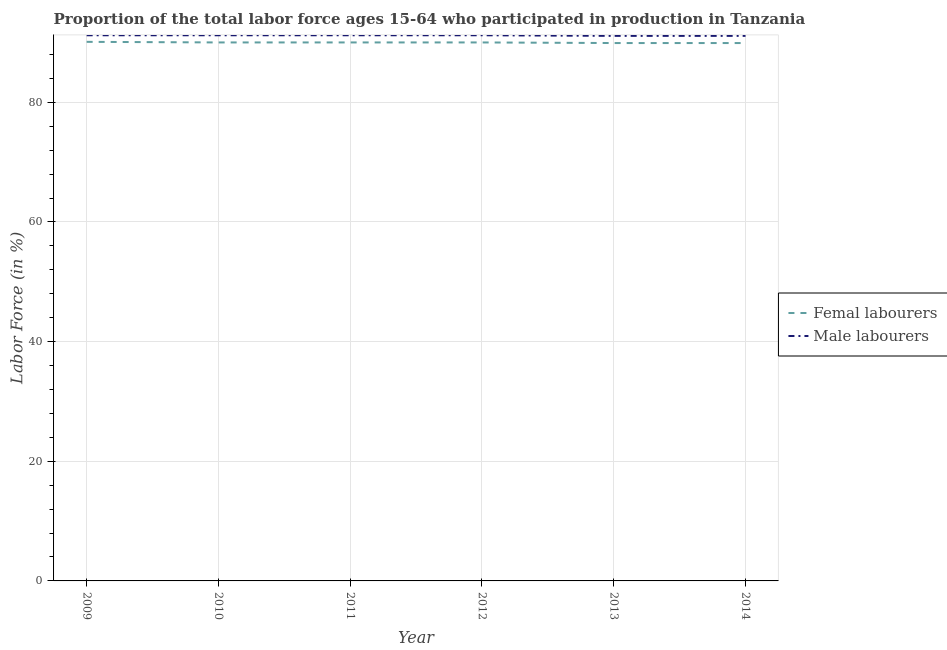Is the number of lines equal to the number of legend labels?
Make the answer very short. Yes. What is the percentage of female labor force in 2014?
Your response must be concise. 89.9. Across all years, what is the maximum percentage of male labour force?
Keep it short and to the point. 91.2. Across all years, what is the minimum percentage of female labor force?
Give a very brief answer. 89.9. In which year was the percentage of male labour force minimum?
Your answer should be compact. 2013. What is the total percentage of female labor force in the graph?
Make the answer very short. 539.9. What is the difference between the percentage of female labor force in 2009 and that in 2011?
Your response must be concise. 0.1. What is the difference between the percentage of male labour force in 2009 and the percentage of female labor force in 2011?
Ensure brevity in your answer.  1.2. What is the average percentage of female labor force per year?
Provide a short and direct response. 89.98. In the year 2011, what is the difference between the percentage of male labour force and percentage of female labor force?
Offer a very short reply. 1.2. In how many years, is the percentage of female labor force greater than 48 %?
Ensure brevity in your answer.  6. What is the ratio of the percentage of female labor force in 2010 to that in 2014?
Keep it short and to the point. 1. Is the percentage of male labour force in 2012 less than that in 2013?
Offer a very short reply. No. Is the difference between the percentage of male labour force in 2012 and 2014 greater than the difference between the percentage of female labor force in 2012 and 2014?
Ensure brevity in your answer.  Yes. What is the difference between the highest and the second highest percentage of male labour force?
Your response must be concise. 0. What is the difference between the highest and the lowest percentage of female labor force?
Your response must be concise. 0.2. Does the percentage of female labor force monotonically increase over the years?
Your response must be concise. No. Is the percentage of male labour force strictly greater than the percentage of female labor force over the years?
Your answer should be compact. Yes. Is the percentage of male labour force strictly less than the percentage of female labor force over the years?
Keep it short and to the point. No. How many lines are there?
Make the answer very short. 2. How many years are there in the graph?
Give a very brief answer. 6. Are the values on the major ticks of Y-axis written in scientific E-notation?
Your answer should be compact. No. Does the graph contain any zero values?
Provide a short and direct response. No. Does the graph contain grids?
Your response must be concise. Yes. How many legend labels are there?
Your response must be concise. 2. How are the legend labels stacked?
Provide a succinct answer. Vertical. What is the title of the graph?
Offer a terse response. Proportion of the total labor force ages 15-64 who participated in production in Tanzania. Does "Grants" appear as one of the legend labels in the graph?
Your answer should be very brief. No. What is the label or title of the X-axis?
Offer a very short reply. Year. What is the label or title of the Y-axis?
Offer a terse response. Labor Force (in %). What is the Labor Force (in %) in Femal labourers in 2009?
Ensure brevity in your answer.  90.1. What is the Labor Force (in %) in Male labourers in 2009?
Offer a terse response. 91.2. What is the Labor Force (in %) of Male labourers in 2010?
Offer a very short reply. 91.2. What is the Labor Force (in %) in Male labourers in 2011?
Your response must be concise. 91.2. What is the Labor Force (in %) in Male labourers in 2012?
Ensure brevity in your answer.  91.2. What is the Labor Force (in %) in Femal labourers in 2013?
Your answer should be compact. 89.9. What is the Labor Force (in %) in Male labourers in 2013?
Your answer should be very brief. 91.1. What is the Labor Force (in %) in Femal labourers in 2014?
Give a very brief answer. 89.9. What is the Labor Force (in %) of Male labourers in 2014?
Ensure brevity in your answer.  91.1. Across all years, what is the maximum Labor Force (in %) of Femal labourers?
Your response must be concise. 90.1. Across all years, what is the maximum Labor Force (in %) of Male labourers?
Your answer should be very brief. 91.2. Across all years, what is the minimum Labor Force (in %) in Femal labourers?
Offer a terse response. 89.9. Across all years, what is the minimum Labor Force (in %) of Male labourers?
Ensure brevity in your answer.  91.1. What is the total Labor Force (in %) of Femal labourers in the graph?
Keep it short and to the point. 539.9. What is the total Labor Force (in %) of Male labourers in the graph?
Ensure brevity in your answer.  547. What is the difference between the Labor Force (in %) in Male labourers in 2009 and that in 2010?
Your response must be concise. 0. What is the difference between the Labor Force (in %) in Femal labourers in 2009 and that in 2012?
Ensure brevity in your answer.  0.1. What is the difference between the Labor Force (in %) of Male labourers in 2009 and that in 2012?
Your response must be concise. 0. What is the difference between the Labor Force (in %) in Femal labourers in 2009 and that in 2014?
Your response must be concise. 0.2. What is the difference between the Labor Force (in %) in Femal labourers in 2010 and that in 2012?
Provide a short and direct response. 0. What is the difference between the Labor Force (in %) of Male labourers in 2010 and that in 2012?
Keep it short and to the point. 0. What is the difference between the Labor Force (in %) of Male labourers in 2010 and that in 2013?
Offer a terse response. 0.1. What is the difference between the Labor Force (in %) in Femal labourers in 2011 and that in 2012?
Provide a succinct answer. 0. What is the difference between the Labor Force (in %) of Male labourers in 2011 and that in 2013?
Your answer should be compact. 0.1. What is the difference between the Labor Force (in %) of Male labourers in 2012 and that in 2013?
Your answer should be very brief. 0.1. What is the difference between the Labor Force (in %) of Femal labourers in 2012 and that in 2014?
Provide a short and direct response. 0.1. What is the difference between the Labor Force (in %) of Femal labourers in 2013 and that in 2014?
Provide a short and direct response. 0. What is the difference between the Labor Force (in %) of Femal labourers in 2009 and the Labor Force (in %) of Male labourers in 2010?
Make the answer very short. -1.1. What is the difference between the Labor Force (in %) in Femal labourers in 2009 and the Labor Force (in %) in Male labourers in 2011?
Your response must be concise. -1.1. What is the difference between the Labor Force (in %) of Femal labourers in 2009 and the Labor Force (in %) of Male labourers in 2014?
Offer a very short reply. -1. What is the difference between the Labor Force (in %) in Femal labourers in 2010 and the Labor Force (in %) in Male labourers in 2012?
Ensure brevity in your answer.  -1.2. What is the difference between the Labor Force (in %) of Femal labourers in 2010 and the Labor Force (in %) of Male labourers in 2013?
Provide a short and direct response. -1.1. What is the difference between the Labor Force (in %) of Femal labourers in 2012 and the Labor Force (in %) of Male labourers in 2014?
Offer a terse response. -1.1. What is the average Labor Force (in %) in Femal labourers per year?
Keep it short and to the point. 89.98. What is the average Labor Force (in %) of Male labourers per year?
Offer a very short reply. 91.17. In the year 2010, what is the difference between the Labor Force (in %) in Femal labourers and Labor Force (in %) in Male labourers?
Ensure brevity in your answer.  -1.2. In the year 2011, what is the difference between the Labor Force (in %) in Femal labourers and Labor Force (in %) in Male labourers?
Offer a very short reply. -1.2. In the year 2012, what is the difference between the Labor Force (in %) of Femal labourers and Labor Force (in %) of Male labourers?
Keep it short and to the point. -1.2. What is the ratio of the Labor Force (in %) of Femal labourers in 2009 to that in 2010?
Give a very brief answer. 1. What is the ratio of the Labor Force (in %) in Male labourers in 2009 to that in 2011?
Provide a succinct answer. 1. What is the ratio of the Labor Force (in %) in Femal labourers in 2009 to that in 2012?
Offer a very short reply. 1. What is the ratio of the Labor Force (in %) in Male labourers in 2009 to that in 2012?
Offer a terse response. 1. What is the ratio of the Labor Force (in %) in Femal labourers in 2009 to that in 2013?
Give a very brief answer. 1. What is the ratio of the Labor Force (in %) in Male labourers in 2009 to that in 2013?
Offer a terse response. 1. What is the ratio of the Labor Force (in %) in Male labourers in 2010 to that in 2012?
Your response must be concise. 1. What is the ratio of the Labor Force (in %) in Male labourers in 2010 to that in 2014?
Your answer should be compact. 1. What is the ratio of the Labor Force (in %) of Femal labourers in 2011 to that in 2012?
Your answer should be compact. 1. What is the ratio of the Labor Force (in %) of Femal labourers in 2011 to that in 2013?
Ensure brevity in your answer.  1. What is the ratio of the Labor Force (in %) in Male labourers in 2011 to that in 2013?
Your answer should be very brief. 1. What is the ratio of the Labor Force (in %) of Femal labourers in 2011 to that in 2014?
Provide a succinct answer. 1. What is the ratio of the Labor Force (in %) in Femal labourers in 2012 to that in 2013?
Make the answer very short. 1. What is the ratio of the Labor Force (in %) in Femal labourers in 2013 to that in 2014?
Offer a very short reply. 1. What is the difference between the highest and the second highest Labor Force (in %) of Femal labourers?
Make the answer very short. 0.1. What is the difference between the highest and the second highest Labor Force (in %) in Male labourers?
Ensure brevity in your answer.  0. What is the difference between the highest and the lowest Labor Force (in %) in Male labourers?
Your response must be concise. 0.1. 